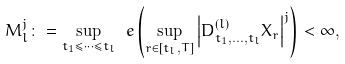Convert formula to latex. <formula><loc_0><loc_0><loc_500><loc_500>M ^ { j } _ { l } \colon = \sup _ { t _ { 1 } \leq \cdots \leq t _ { l } } \ e \left ( \sup _ { r \in [ t _ { l } , T ] } \left | D ^ { ( l ) } _ { t _ { 1 } , \dots , t _ { l } } X _ { r } \right | ^ { j } \right ) < \infty ,</formula> 